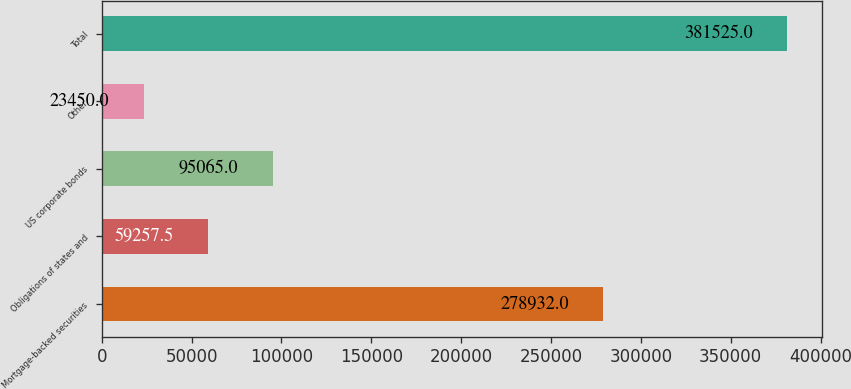<chart> <loc_0><loc_0><loc_500><loc_500><bar_chart><fcel>Mortgage-backed securities<fcel>Obligations of states and<fcel>US corporate bonds<fcel>Other<fcel>Total<nl><fcel>278932<fcel>59257.5<fcel>95065<fcel>23450<fcel>381525<nl></chart> 